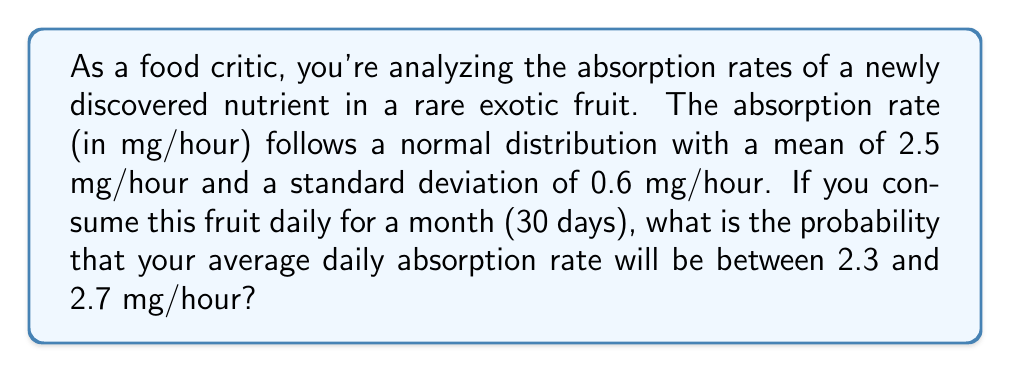Can you solve this math problem? To solve this problem, we'll use the properties of normal distributions and the Central Limit Theorem.

1. Given information:
   - Individual absorption rate: $X \sim N(\mu = 2.5, \sigma = 0.6)$
   - Number of days (sample size): $n = 30$
   - We need to find: $P(2.3 < \bar{X} < 2.7)$

2. By the Central Limit Theorem, the sampling distribution of the mean $\bar{X}$ is also normally distributed:
   $\bar{X} \sim N(\mu_{\bar{X}} = \mu, \sigma_{\bar{X}} = \frac{\sigma}{\sqrt{n}})$

3. Calculate the standard error of the mean:
   $\sigma_{\bar{X}} = \frac{0.6}{\sqrt{30}} = 0.1095$

4. Standardize the z-scores for the upper and lower bounds:
   $z_{lower} = \frac{2.3 - 2.5}{0.1095} = -1.8265$
   $z_{upper} = \frac{2.7 - 2.5}{0.1095} = 1.8265$

5. Use the standard normal distribution table or a calculator to find the probabilities:
   $P(Z < -1.8265) = 0.0339$
   $P(Z < 1.8265) = 0.9661$

6. Calculate the probability between these z-scores:
   $P(-1.8265 < Z < 1.8265) = 0.9661 - 0.0339 = 0.9322$

Therefore, the probability that your average daily absorption rate will be between 2.3 and 2.7 mg/hour is approximately 0.9322 or 93.22%.
Answer: 0.9322 or 93.22% 